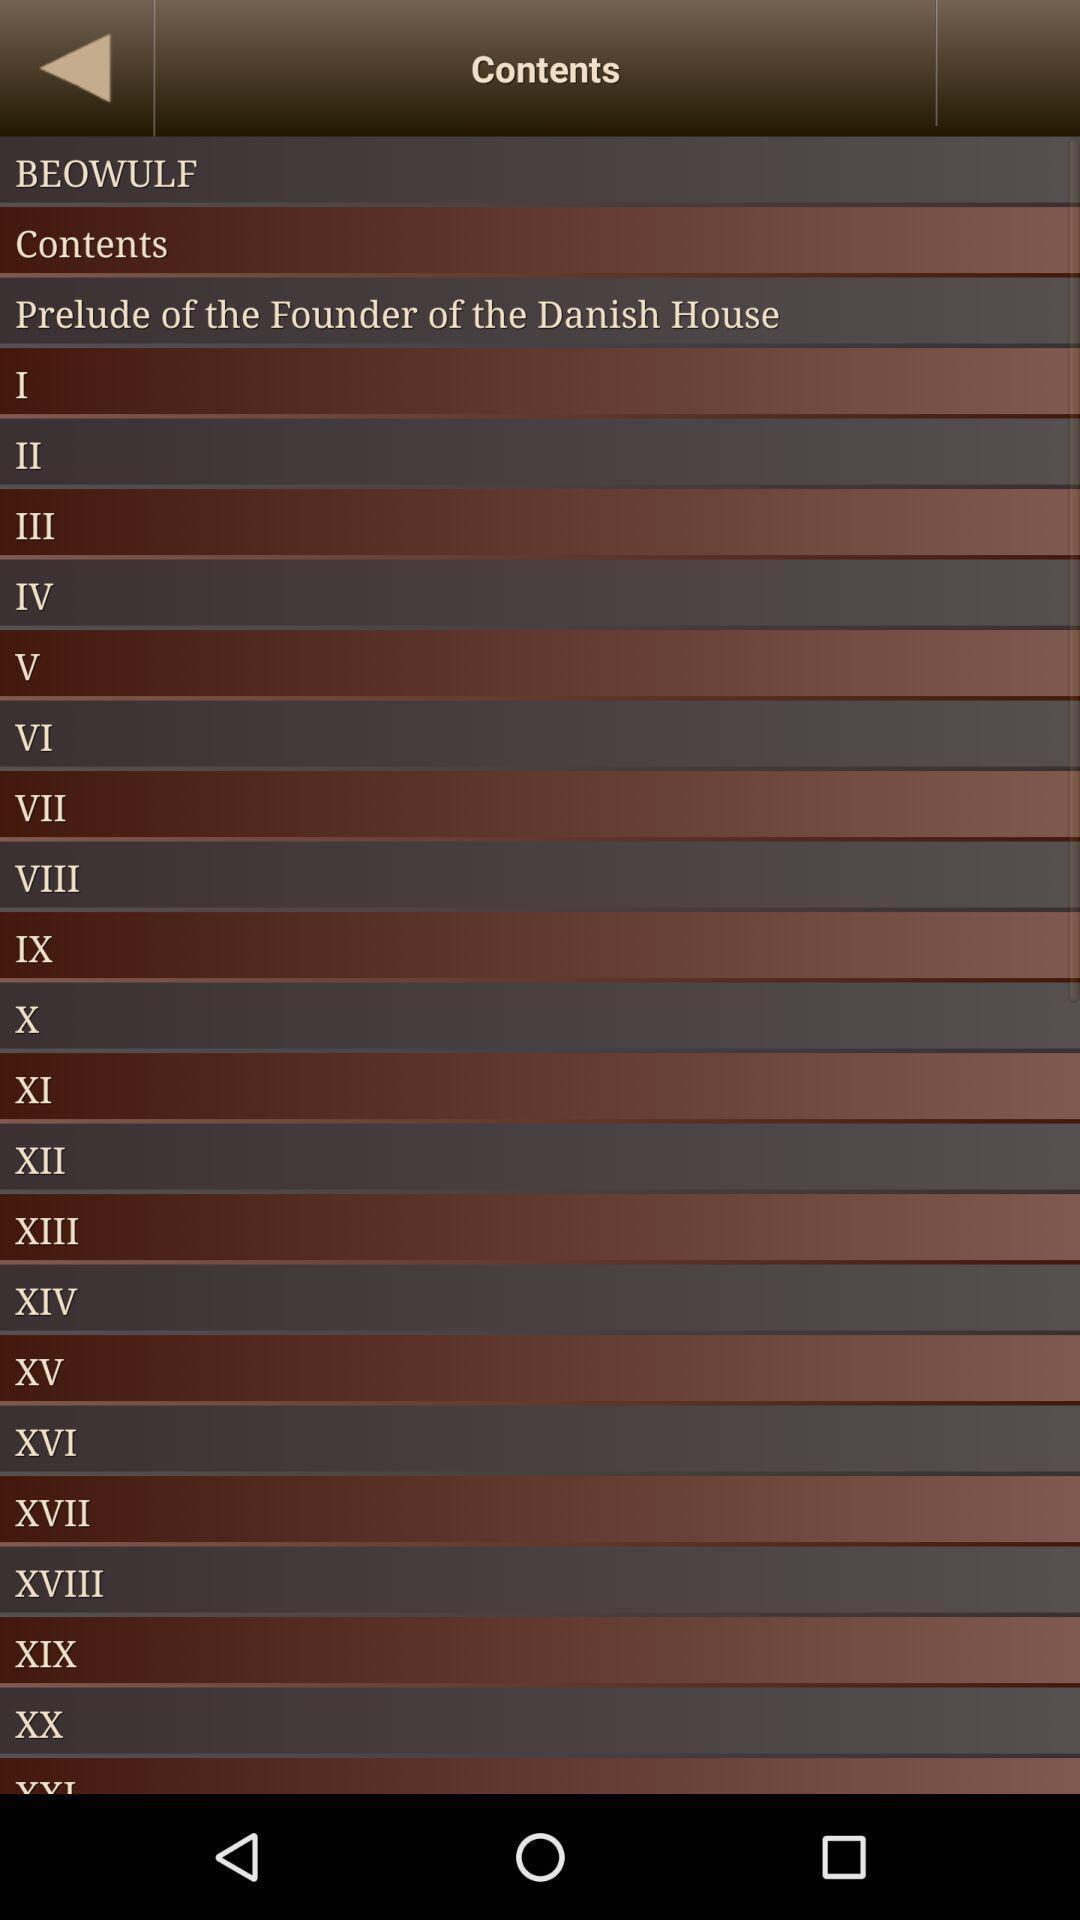Tell me about the visual elements in this screen capture. Page shows about the contents for popular books. 